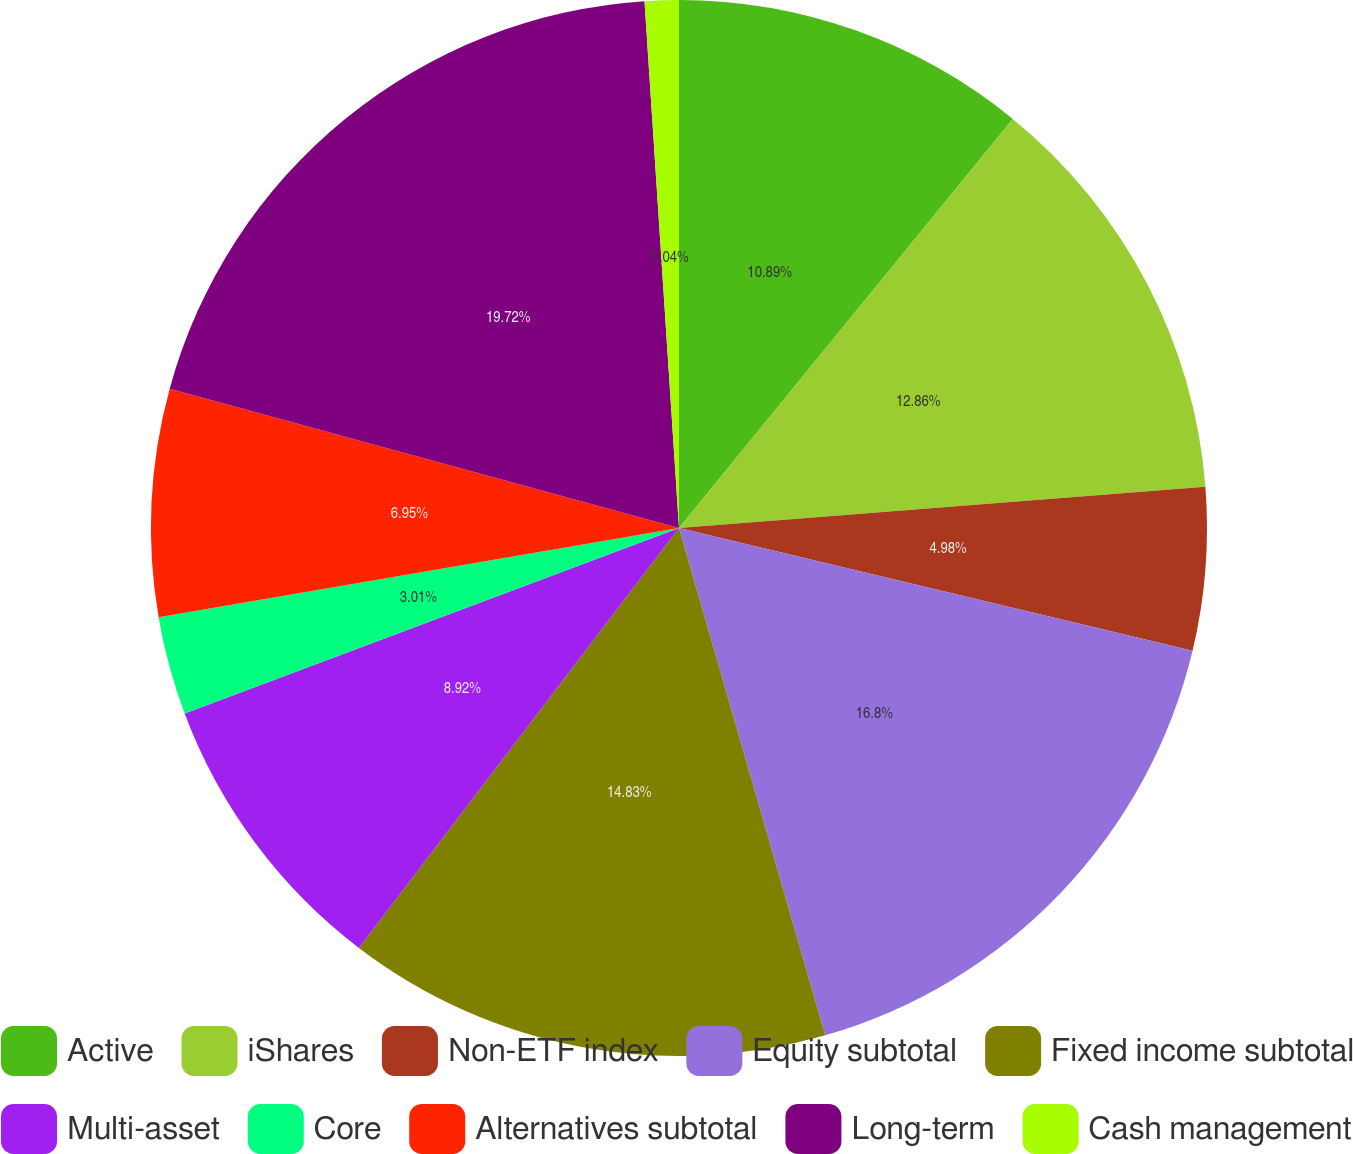<chart> <loc_0><loc_0><loc_500><loc_500><pie_chart><fcel>Active<fcel>iShares<fcel>Non-ETF index<fcel>Equity subtotal<fcel>Fixed income subtotal<fcel>Multi-asset<fcel>Core<fcel>Alternatives subtotal<fcel>Long-term<fcel>Cash management<nl><fcel>10.89%<fcel>12.86%<fcel>4.98%<fcel>16.8%<fcel>14.83%<fcel>8.92%<fcel>3.01%<fcel>6.95%<fcel>19.71%<fcel>1.04%<nl></chart> 